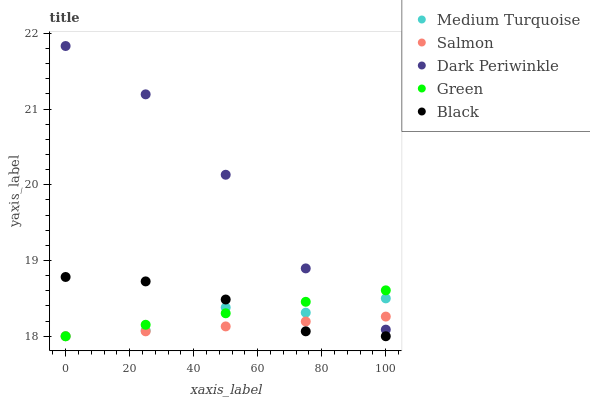Does Salmon have the minimum area under the curve?
Answer yes or no. Yes. Does Dark Periwinkle have the maximum area under the curve?
Answer yes or no. Yes. Does Dark Periwinkle have the minimum area under the curve?
Answer yes or no. No. Does Salmon have the maximum area under the curve?
Answer yes or no. No. Is Green the smoothest?
Answer yes or no. Yes. Is Dark Periwinkle the roughest?
Answer yes or no. Yes. Is Dark Periwinkle the smoothest?
Answer yes or no. No. Is Salmon the roughest?
Answer yes or no. No. Does Green have the lowest value?
Answer yes or no. Yes. Does Dark Periwinkle have the lowest value?
Answer yes or no. No. Does Dark Periwinkle have the highest value?
Answer yes or no. Yes. Does Salmon have the highest value?
Answer yes or no. No. Is Black less than Dark Periwinkle?
Answer yes or no. Yes. Is Dark Periwinkle greater than Black?
Answer yes or no. Yes. Does Black intersect Green?
Answer yes or no. Yes. Is Black less than Green?
Answer yes or no. No. Is Black greater than Green?
Answer yes or no. No. Does Black intersect Dark Periwinkle?
Answer yes or no. No. 